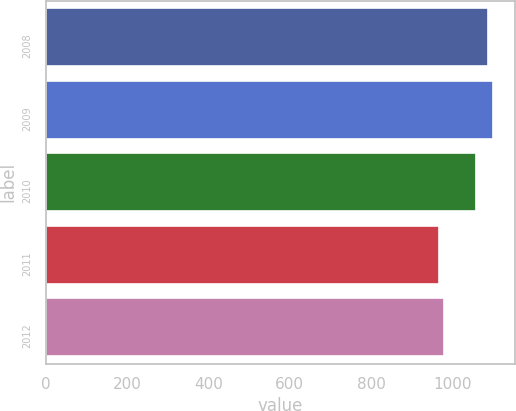<chart> <loc_0><loc_0><loc_500><loc_500><bar_chart><fcel>2008<fcel>2009<fcel>2010<fcel>2011<fcel>2012<nl><fcel>1087<fcel>1099<fcel>1059<fcel>967<fcel>979<nl></chart> 